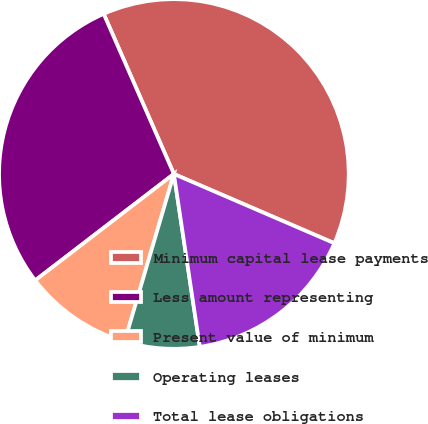<chart> <loc_0><loc_0><loc_500><loc_500><pie_chart><fcel>Minimum capital lease payments<fcel>Less amount representing<fcel>Present value of minimum<fcel>Operating leases<fcel>Total lease obligations<nl><fcel>38.06%<fcel>28.84%<fcel>10.03%<fcel>6.92%<fcel>16.15%<nl></chart> 